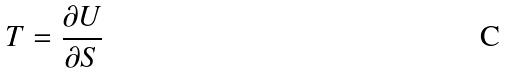Convert formula to latex. <formula><loc_0><loc_0><loc_500><loc_500>T = \frac { \partial U } { \partial S }</formula> 